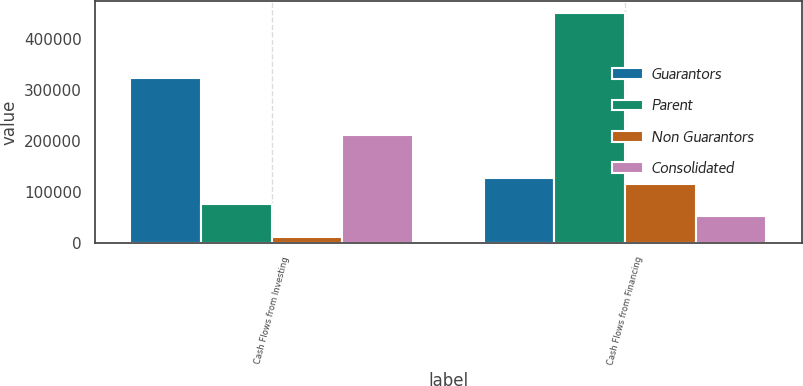Convert chart. <chart><loc_0><loc_0><loc_500><loc_500><stacked_bar_chart><ecel><fcel>Cash Flows from Investing<fcel>Cash Flows from Financing<nl><fcel>Guarantors<fcel>323902<fcel>126873<nl><fcel>Parent<fcel>74968<fcel>451083<nl><fcel>Non Guarantors<fcel>10207<fcel>115922<nl><fcel>Consolidated<fcel>212177<fcel>53142<nl></chart> 